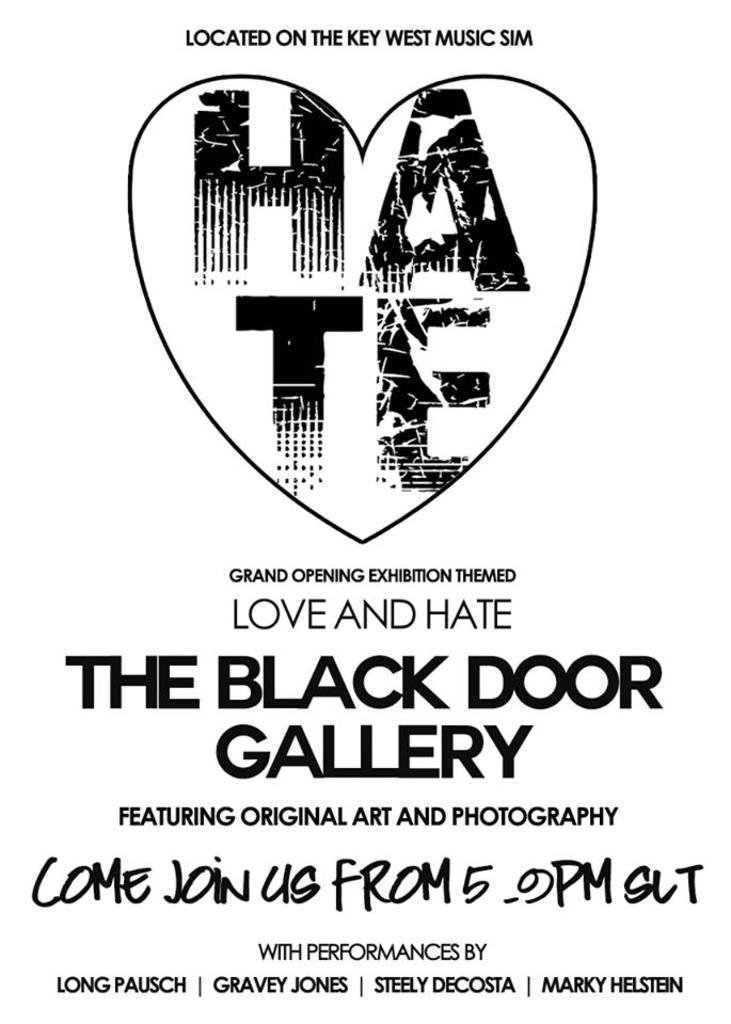<image>
Create a compact narrative representing the image presented. A poster advertises the Black Door Gallery, which is located on the Key West Music Sim. 